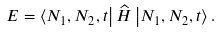Convert formula to latex. <formula><loc_0><loc_0><loc_500><loc_500>E = \left \langle N _ { 1 } , N _ { 2 } , t \right | \widehat { H } \left | N _ { 1 } , N _ { 2 } , t \right \rangle .</formula> 